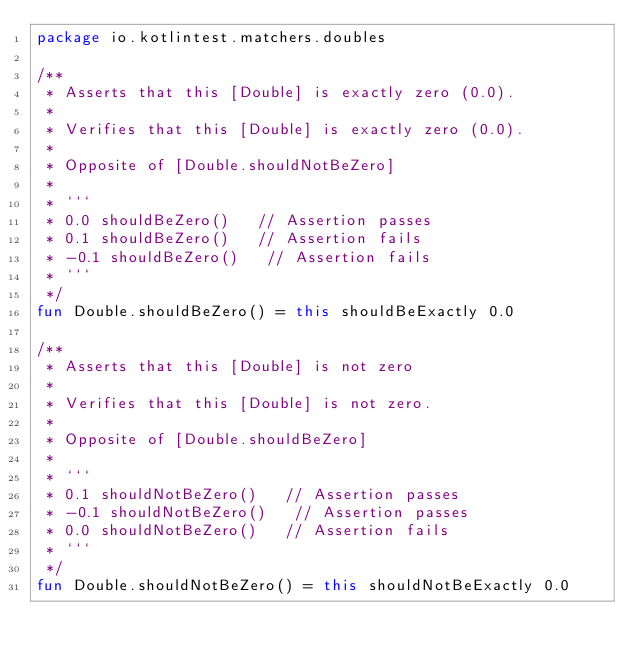<code> <loc_0><loc_0><loc_500><loc_500><_Kotlin_>package io.kotlintest.matchers.doubles

/**
 * Asserts that this [Double] is exactly zero (0.0).
 *
 * Verifies that this [Double] is exactly zero (0.0).
 *
 * Opposite of [Double.shouldNotBeZero]
 *
 * ```
 * 0.0 shouldBeZero()   // Assertion passes
 * 0.1 shouldBeZero()   // Assertion fails
 * -0.1 shouldBeZero()   // Assertion fails
 * ```
 */
fun Double.shouldBeZero() = this shouldBeExactly 0.0

/**
 * Asserts that this [Double] is not zero
 *
 * Verifies that this [Double] is not zero.
 *
 * Opposite of [Double.shouldBeZero]
 *
 * ```
 * 0.1 shouldNotBeZero()   // Assertion passes
 * -0.1 shouldNotBeZero()   // Assertion passes
 * 0.0 shouldNotBeZero()   // Assertion fails
 * ```
 */
fun Double.shouldNotBeZero() = this shouldNotBeExactly 0.0</code> 